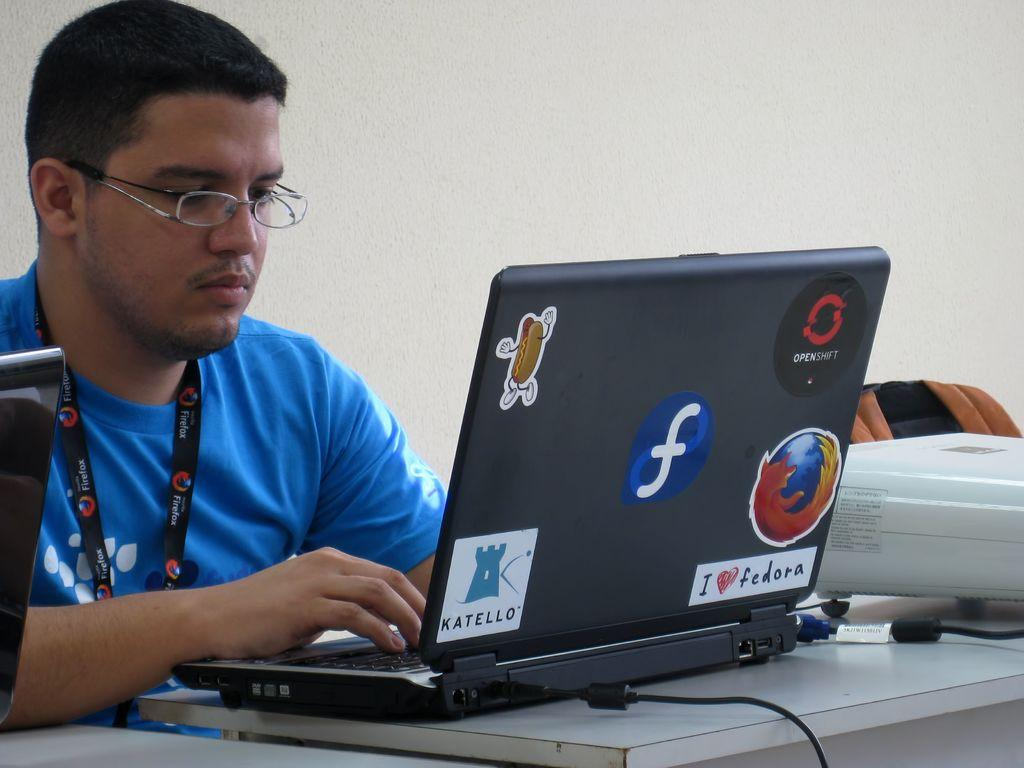<image>
Write a terse but informative summary of the picture. Person using a laptop with a sticker that says Katello. 